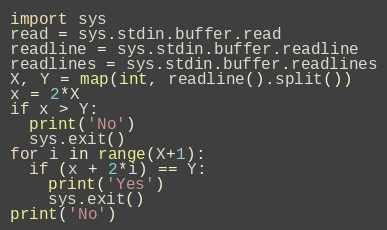Convert code to text. <code><loc_0><loc_0><loc_500><loc_500><_Python_>import sys 
read = sys.stdin.buffer.read
readline = sys.stdin.buffer.readline
readlines = sys.stdin.buffer.readlines
X, Y = map(int, readline().split())
x = 2*X
if x > Y:
  print('No')
  sys.exit()
for i in range(X+1):
  if (x + 2*i) == Y:
    print('Yes')
    sys.exit()
print('No')</code> 